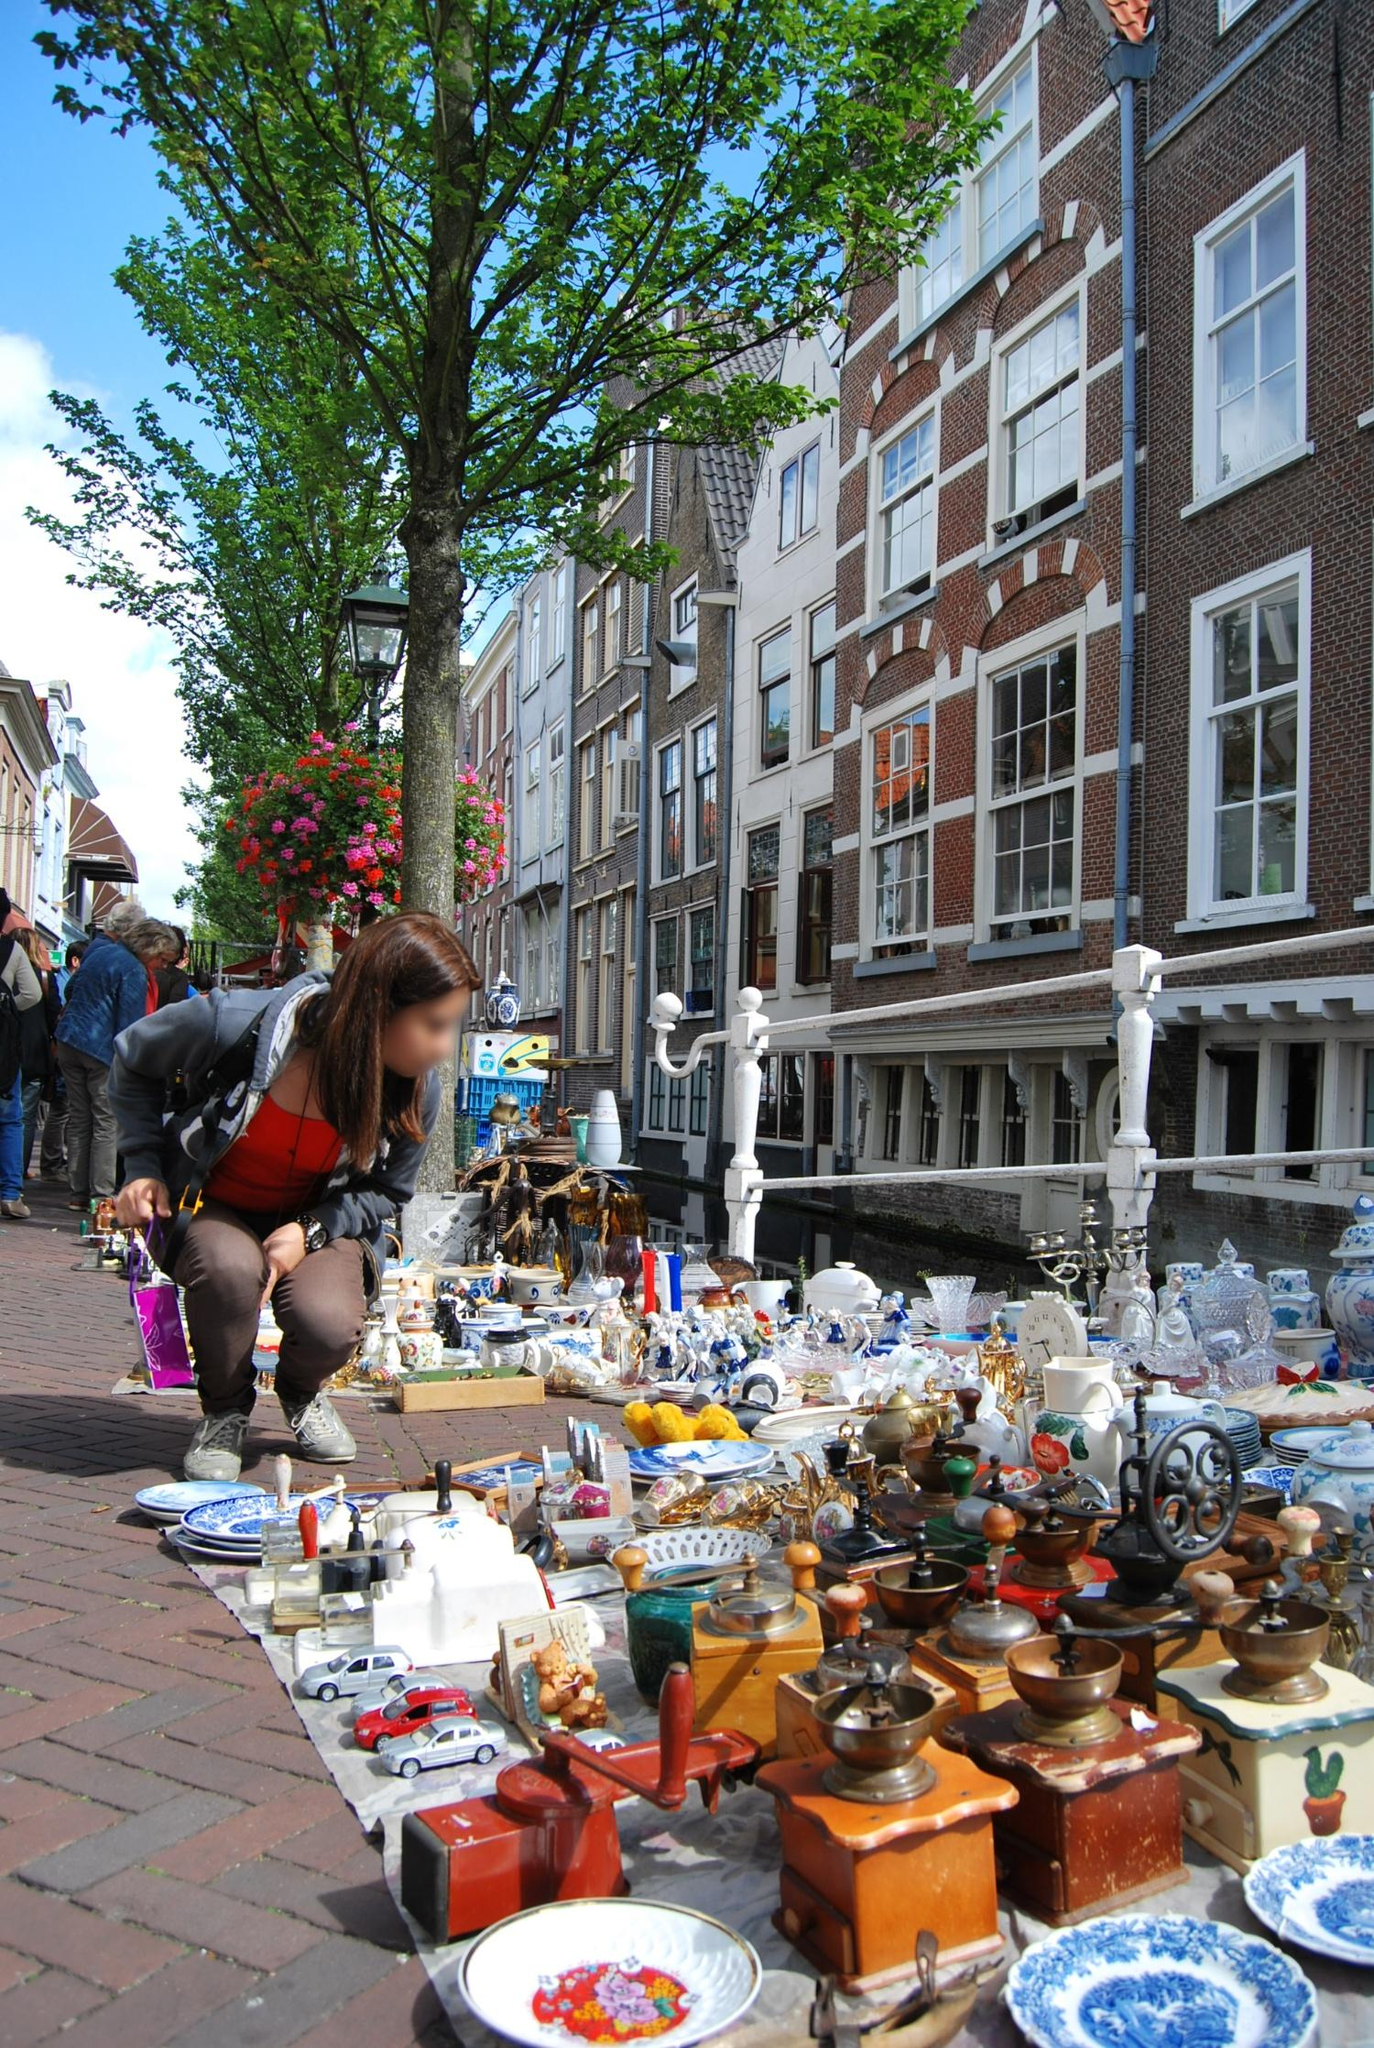If you could transform this image into a fantastical scene, what would it look like? In a fantastical transformation, the street market in the image becomes a bustling bazaar in an enchanted city where magic is woven into everyday life. The market stalls are now filled with not just trinkets and antiques but mystical artifacts, shimmering potions, and spell books. The trees lining the street are alive, with leaves that change colors and whisper secrets to passersby. Hanging lanterns float in the air, casting a warm, ethereal glow that illuminates the cobblestone path.

The buildings, though retaining their Amsterdam charm, are now interspersed with whimsical architecture — some seem to defy gravity with intricate spires reaching towards the sky, while others have walls adorned with living murals that shift and change, telling stories of old adventures and mythical creatures.

People in the market wear robes of vibrant, magical fabrics that shimmer with each movement. Street performers aren't just musicians but also illusionists conjuring captivating displays of light and magic. The canals reflect a surreal twilight, with boats gliding effortlessly, often manned by creatures from folklore. The air is filled with an enchanting melody, the blend of fantastical elements creating a dreamlike atmosphere that blurs the boundaries between reality and imagination. 